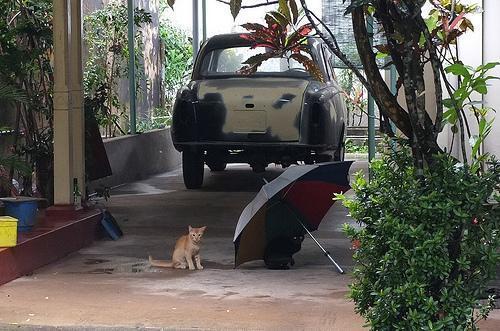How many cats are in the picture?
Give a very brief answer. 2. 